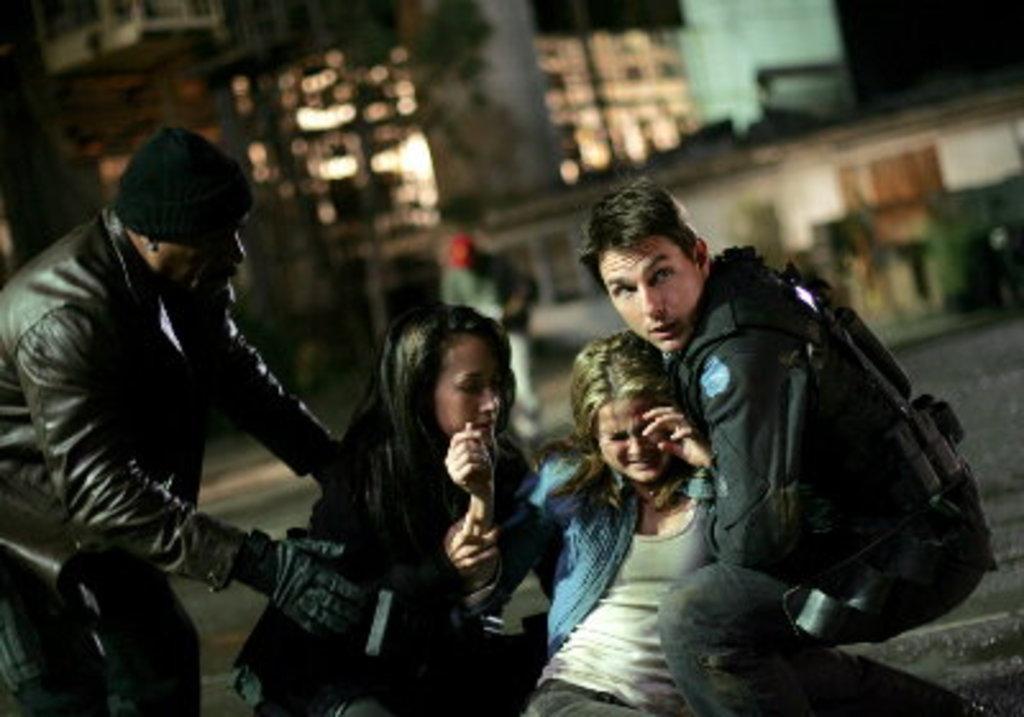How would you summarize this image in a sentence or two? This picture is clicked outside. On the right we can see a person seems to be holding a woman. On the left we can see the two persons. In the background we can see the buildings, lights and some other objects and we can see a person seems to be walking on the ground. 